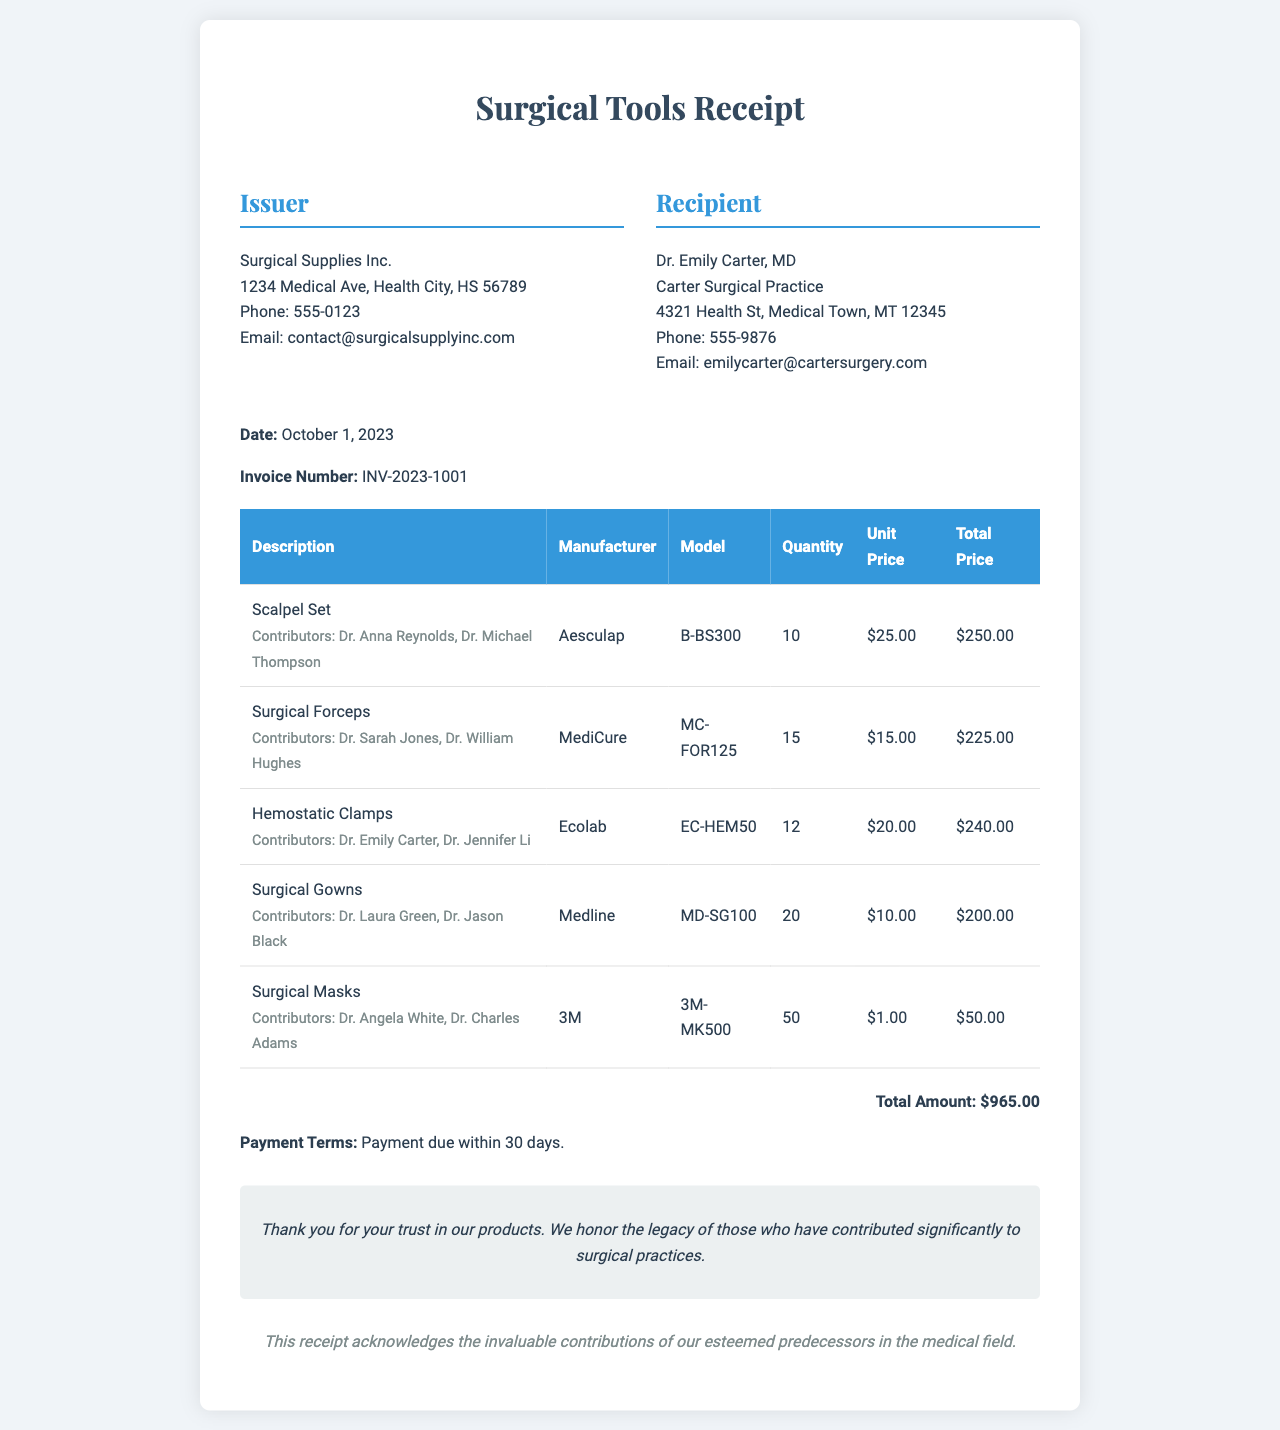what is the total amount? The total amount is explicitly stated at the end of the document after listing all the items.
Answer: $965.00 who issued the receipt? The issuer of the receipt is detailed in the top section, including the name and contact information.
Answer: Surgical Supplies Inc how many surgical gowns were purchased? The document lists the quantity of surgical gowns directly in the table of items.
Answer: 20 who are the contributors for the hemostatic clamps? The contributors for each item are mentioned right under the product description in the document.
Answer: Dr. Emily Carter, Dr. Jennifer Li what is the invoice number? The invoice number is clearly indicated in the document under the date.
Answer: INV-2023-1001 what is the payment term stated in the receipt? The payment terms are directly mentioned at the bottom of the document, outlining the time frame for payment.
Answer: Payment due within 30 days which manufacturer produced the surgical forceps? The document provides the manufacturer's information in the table alongside each item description.
Answer: MediCure how many units of surgical masks were purchased? The quantity purchased is listed in the table of items in the document.
Answer: 50 who is the recipient of this receipt? The recipient's information is provided in the header section of the document.
Answer: Dr. Emily Carter, MD 